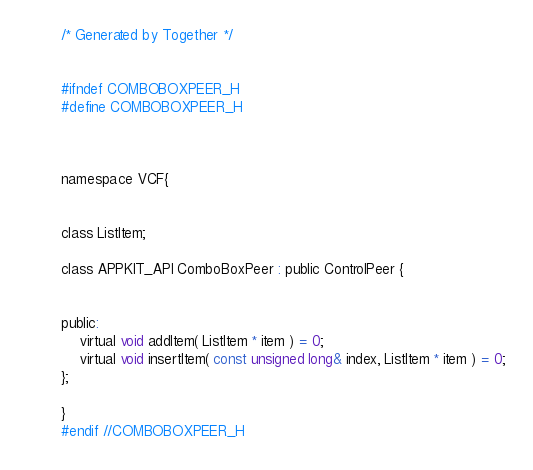Convert code to text. <code><loc_0><loc_0><loc_500><loc_500><_C_>/* Generated by Together */


#ifndef COMBOBOXPEER_H
#define COMBOBOXPEER_H



namespace VCF{


class ListItem;

class APPKIT_API ComboBoxPeer : public ControlPeer {
    

public:
    virtual void addItem( ListItem * item ) = 0;
    virtual void insertItem( const unsigned long& index, ListItem * item ) = 0;
};

}
#endif //COMBOBOXPEER_H</code> 